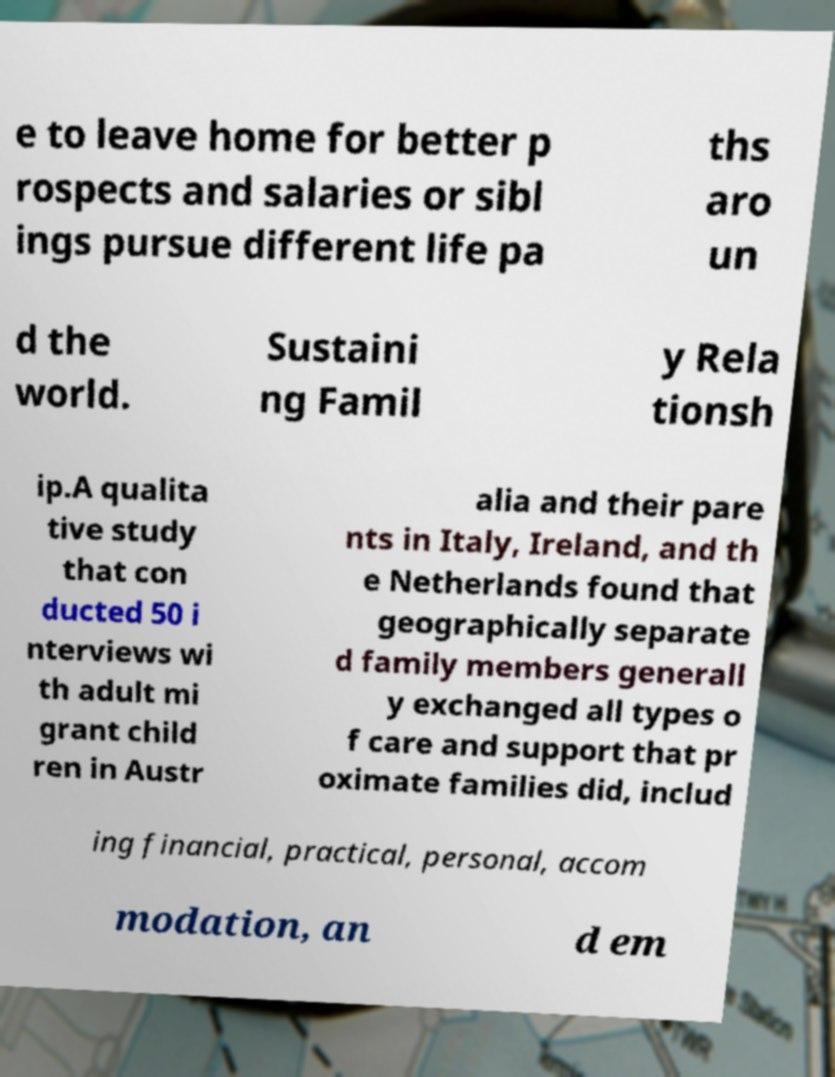What messages or text are displayed in this image? I need them in a readable, typed format. e to leave home for better p rospects and salaries or sibl ings pursue different life pa ths aro un d the world. Sustaini ng Famil y Rela tionsh ip.A qualita tive study that con ducted 50 i nterviews wi th adult mi grant child ren in Austr alia and their pare nts in Italy, Ireland, and th e Netherlands found that geographically separate d family members generall y exchanged all types o f care and support that pr oximate families did, includ ing financial, practical, personal, accom modation, an d em 